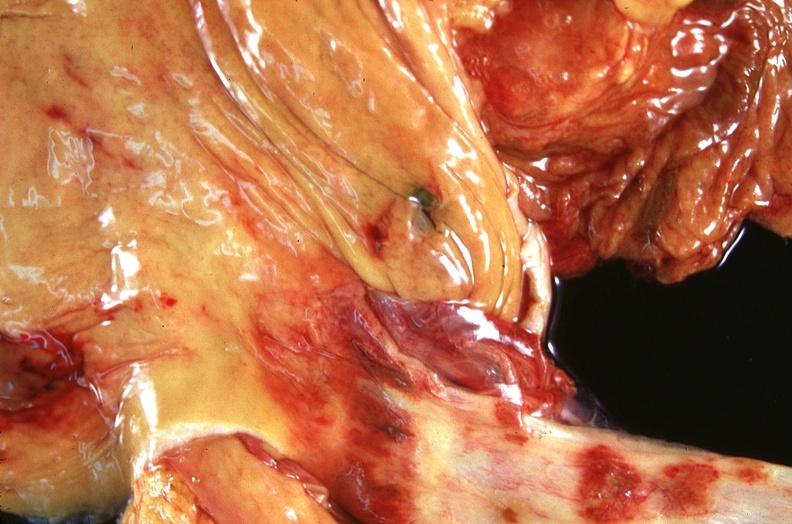what is present?
Answer the question using a single word or phrase. Gastrointestinal 